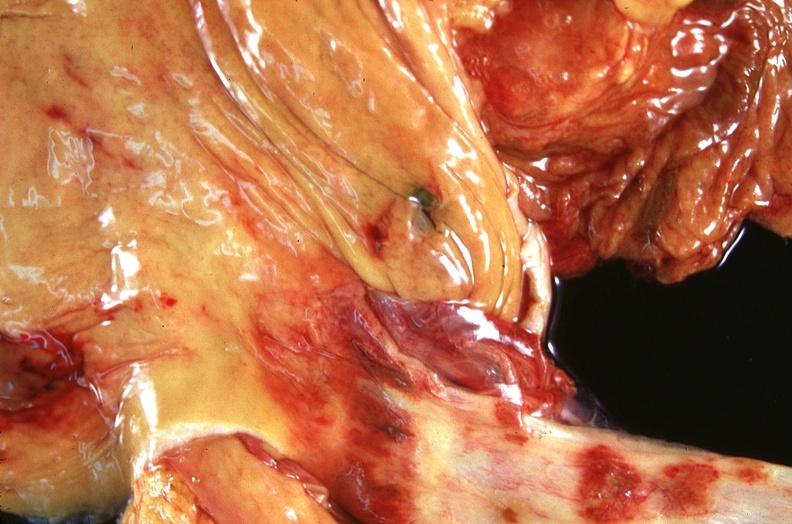what is present?
Answer the question using a single word or phrase. Gastrointestinal 